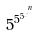Convert formula to latex. <formula><loc_0><loc_0><loc_500><loc_500>5 ^ { 5 ^ { 5 ^ { . ^ { . ^ { n } } } } }</formula> 